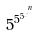Convert formula to latex. <formula><loc_0><loc_0><loc_500><loc_500>5 ^ { 5 ^ { 5 ^ { . ^ { . ^ { n } } } } }</formula> 